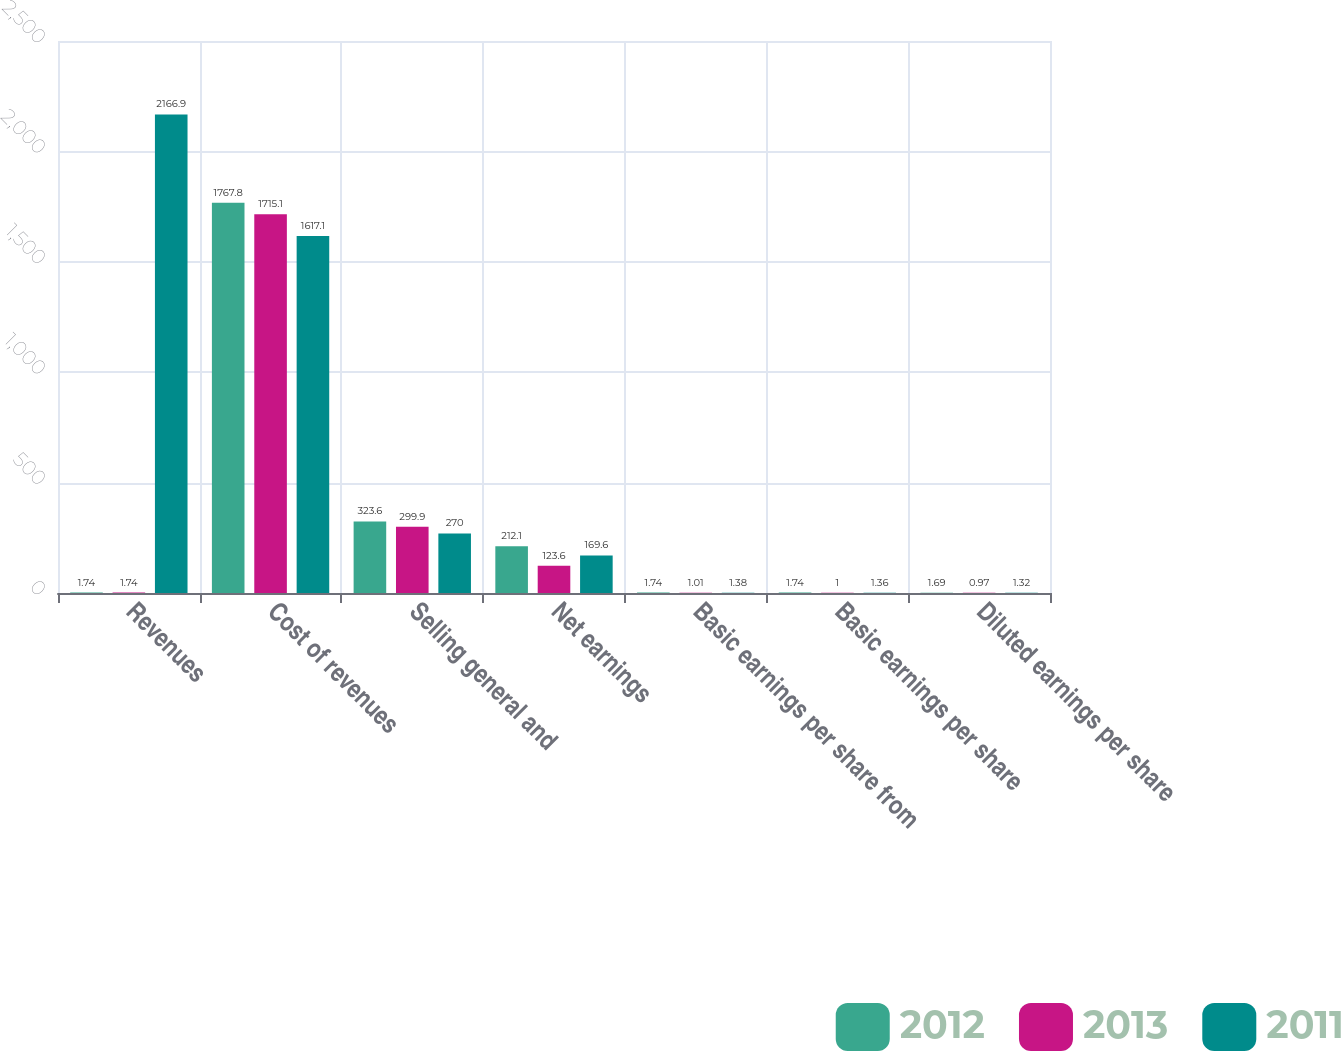Convert chart. <chart><loc_0><loc_0><loc_500><loc_500><stacked_bar_chart><ecel><fcel>Revenues<fcel>Cost of revenues<fcel>Selling general and<fcel>Net earnings<fcel>Basic earnings per share from<fcel>Basic earnings per share<fcel>Diluted earnings per share<nl><fcel>2012<fcel>1.74<fcel>1767.8<fcel>323.6<fcel>212.1<fcel>1.74<fcel>1.74<fcel>1.69<nl><fcel>2013<fcel>1.74<fcel>1715.1<fcel>299.9<fcel>123.6<fcel>1.01<fcel>1<fcel>0.97<nl><fcel>2011<fcel>2166.9<fcel>1617.1<fcel>270<fcel>169.6<fcel>1.38<fcel>1.36<fcel>1.32<nl></chart> 